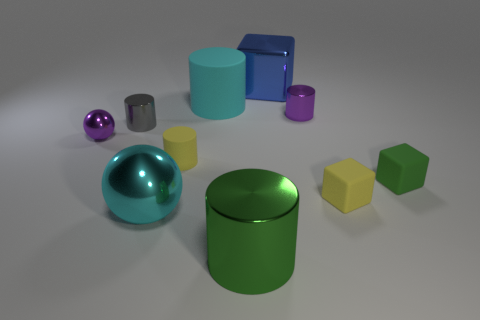There is a tiny purple thing that is to the left of the large cylinder in front of the large cylinder behind the tiny purple sphere; what shape is it? The tiny purple object in question, situated to the left of the large cylinder overlapping in the visual field with another large cylinder and located behind the tiny purple sphere, is actually a small purple cylinder, not a sphere. 